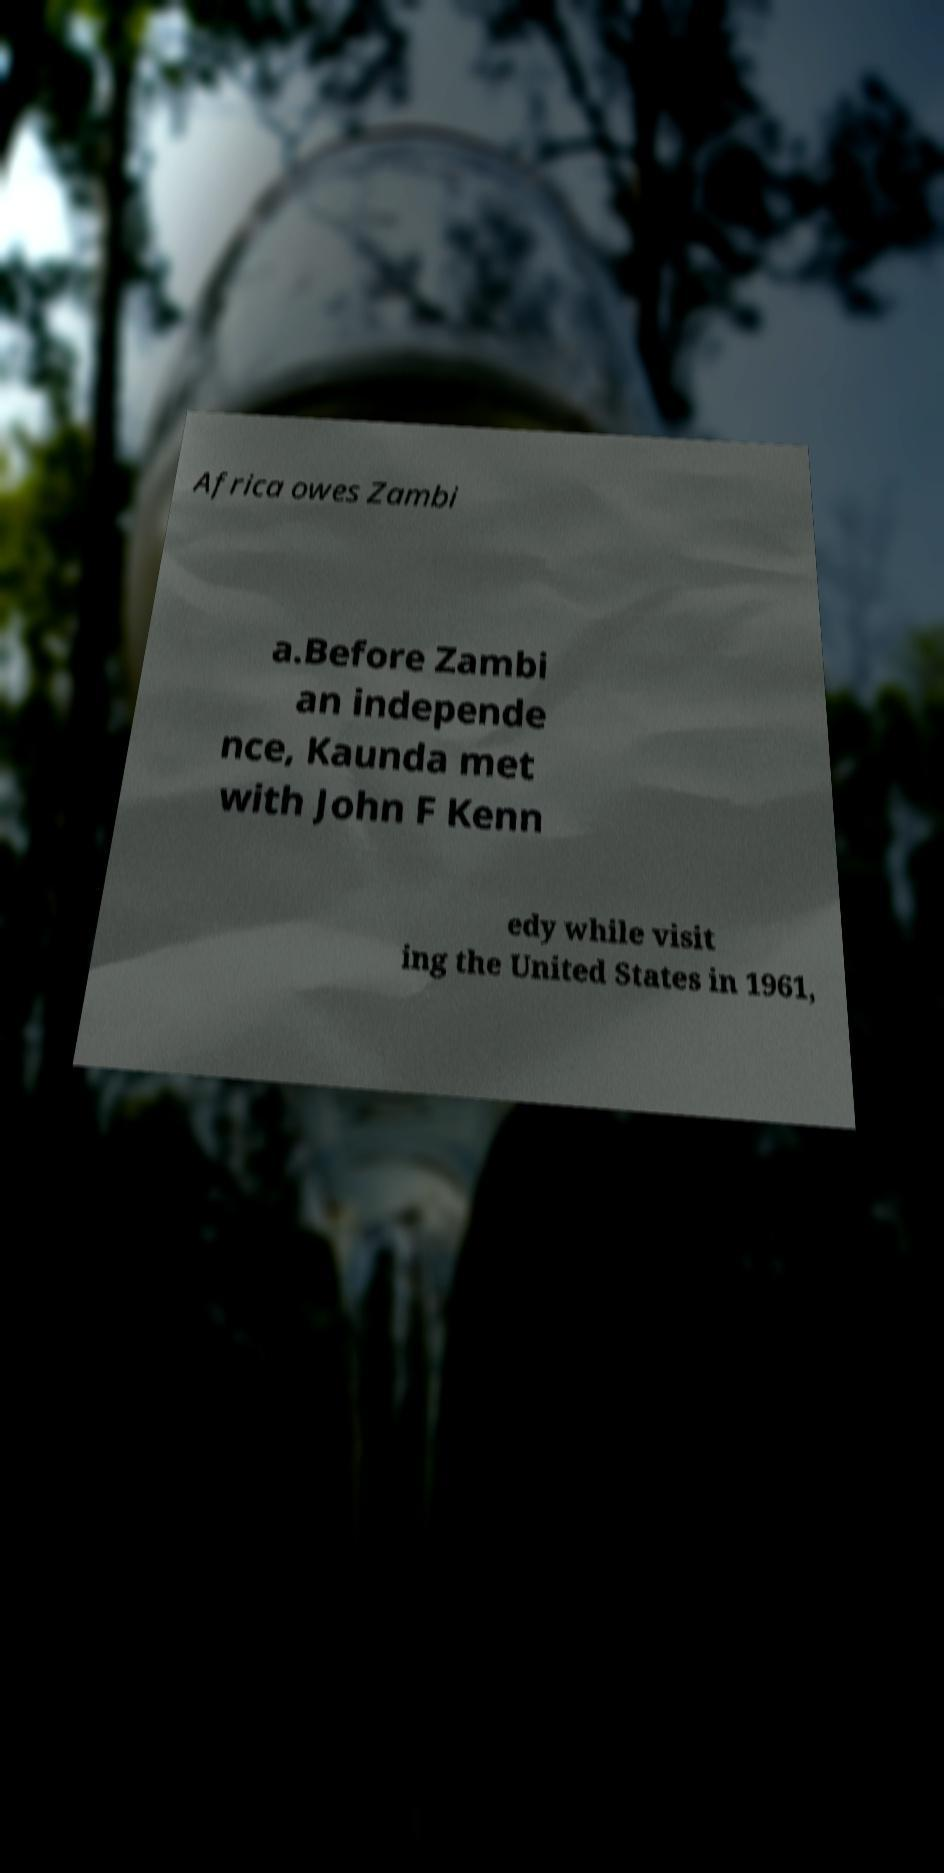Could you extract and type out the text from this image? Africa owes Zambi a.Before Zambi an independe nce, Kaunda met with John F Kenn edy while visit ing the United States in 1961, 